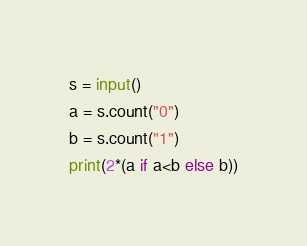Convert code to text. <code><loc_0><loc_0><loc_500><loc_500><_Python_>s = input()
a = s.count("0")
b = s.count("1")
print(2*(a if a<b else b))</code> 